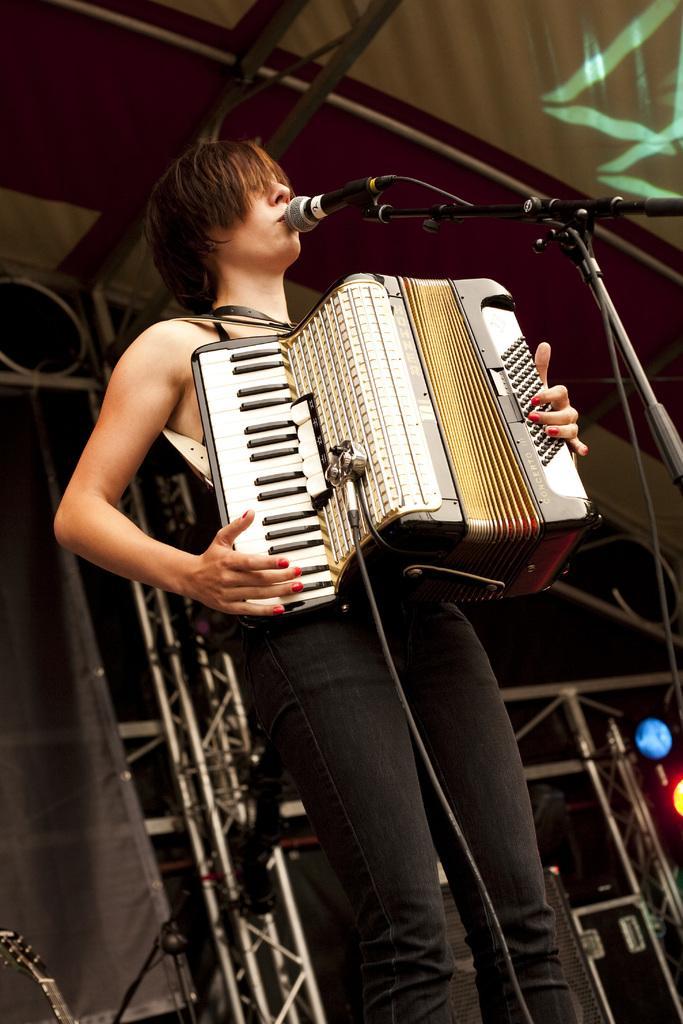Could you give a brief overview of what you see in this image? In the picture there is a person standing near the microphone and playing a musical instrument, there are cables present, behind there are iron poles present. 